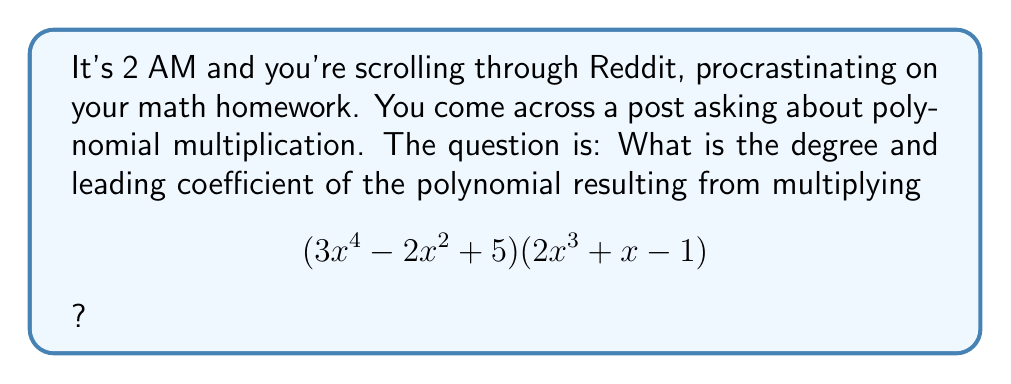Solve this math problem. Let's approach this step-by-step:

1) To find the degree of the resulting polynomial, we add the degrees of the two polynomials being multiplied:
   Degree of $(3x^4 - 2x^2 + 5)$ is 4
   Degree of $(2x^3 + x - 1)$ is 3
   $4 + 3 = 7$, so the resulting polynomial will be of degree 7

2) To find the leading coefficient, we multiply the coefficients of the highest degree terms:
   Leading coefficient of $(3x^4 - 2x^2 + 5)$ is 3
   Leading coefficient of $(2x^3 + x - 1)$ is 2
   $3 * 2 = 6$

3) Therefore, the term with the highest degree in the resulting polynomial will be $6x^7$

4) We don't need to actually perform the full multiplication to answer this question, as the degree and leading coefficient are determined by the highest degree terms of the factors.

5) If we were to expand fully, it would look like this:
   $$(3x^4 - 2x^2 + 5)(2x^3 + x - 1) = 6x^7 + 3x^5 - 3x^4 - 4x^5 - 2x^3 + 2x^2 + 10x^3 + 5x - 5$$

   But this expansion isn't necessary to answer the question at hand.
Answer: Degree: 7; Leading coefficient: 6 